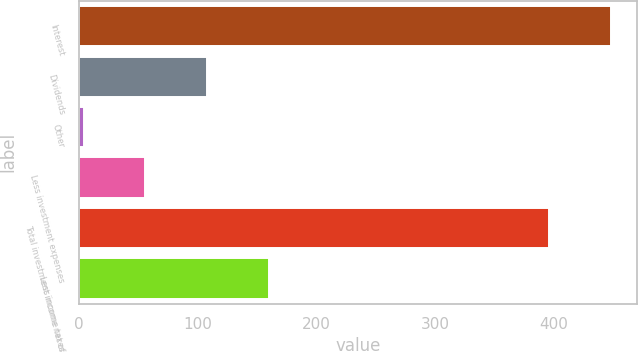Convert chart to OTSL. <chart><loc_0><loc_0><loc_500><loc_500><bar_chart><fcel>Interest<fcel>Dividends<fcel>Other<fcel>Less investment expenses<fcel>Total investment income net of<fcel>Less income taxes<nl><fcel>448.1<fcel>108.2<fcel>4<fcel>56.1<fcel>396<fcel>160.3<nl></chart> 